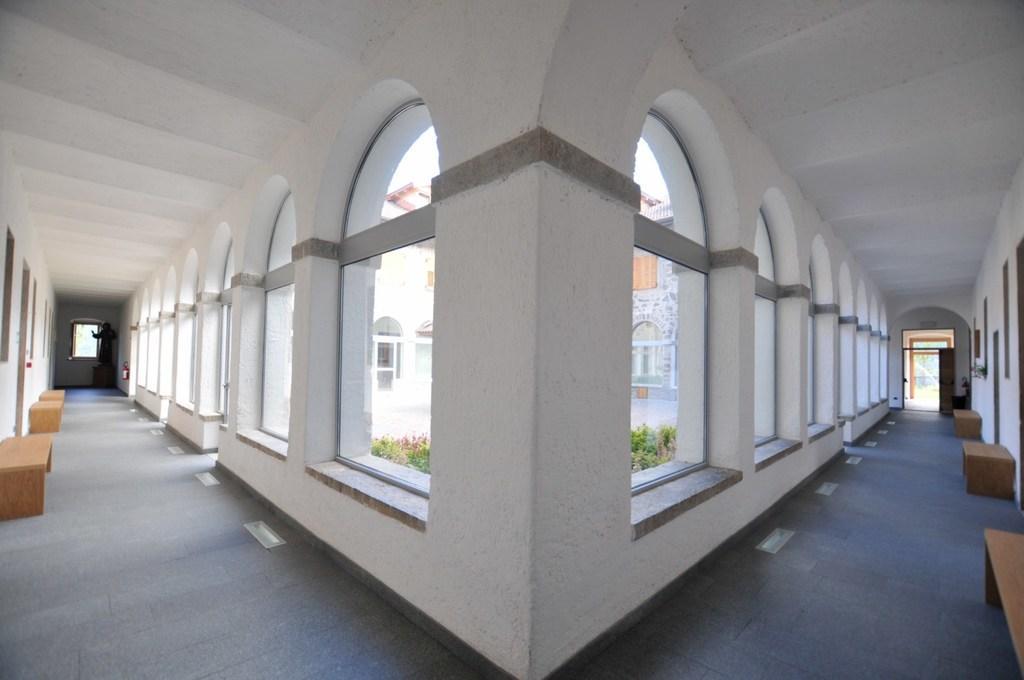Can you describe this image briefly? This is a building and here we can see some benches and there are windows to the wall. 